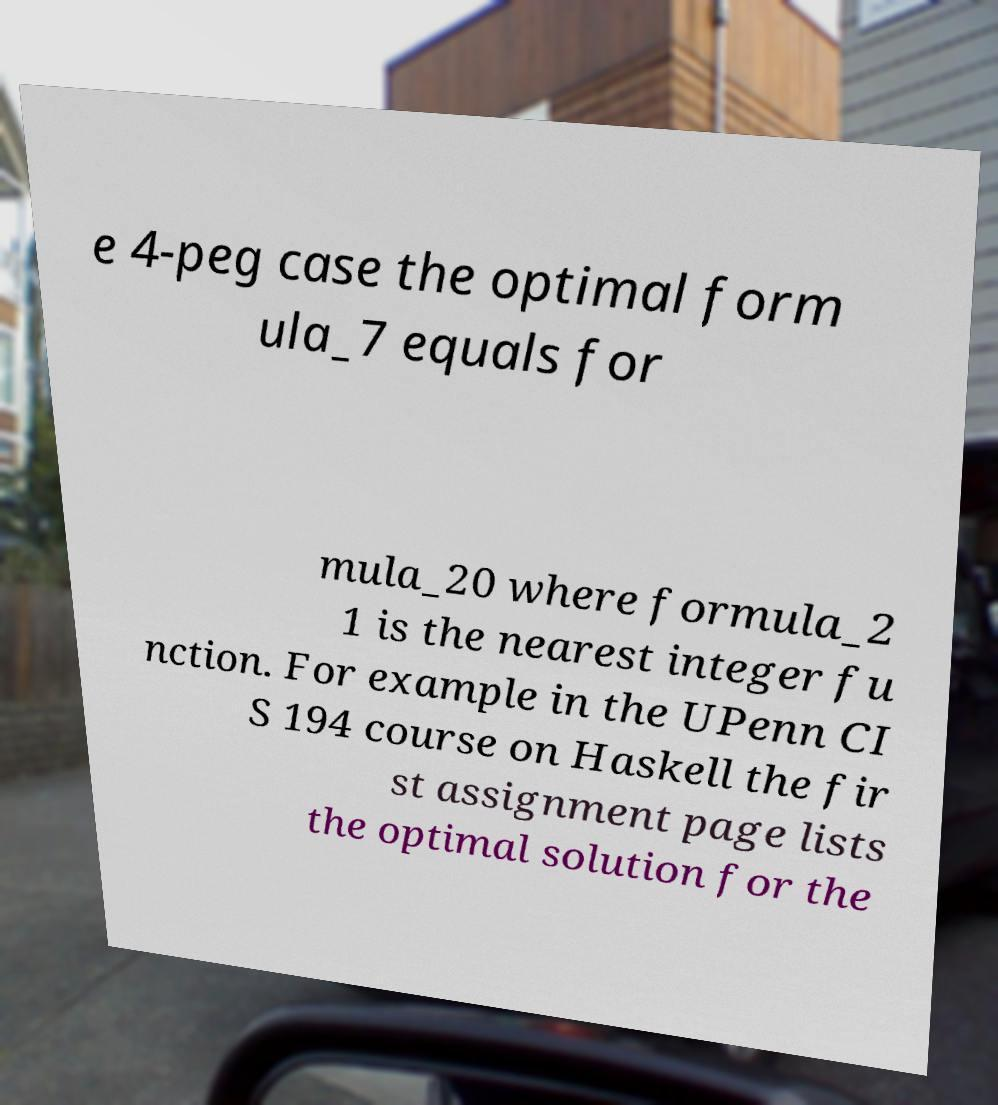What messages or text are displayed in this image? I need them in a readable, typed format. e 4-peg case the optimal form ula_7 equals for mula_20 where formula_2 1 is the nearest integer fu nction. For example in the UPenn CI S 194 course on Haskell the fir st assignment page lists the optimal solution for the 